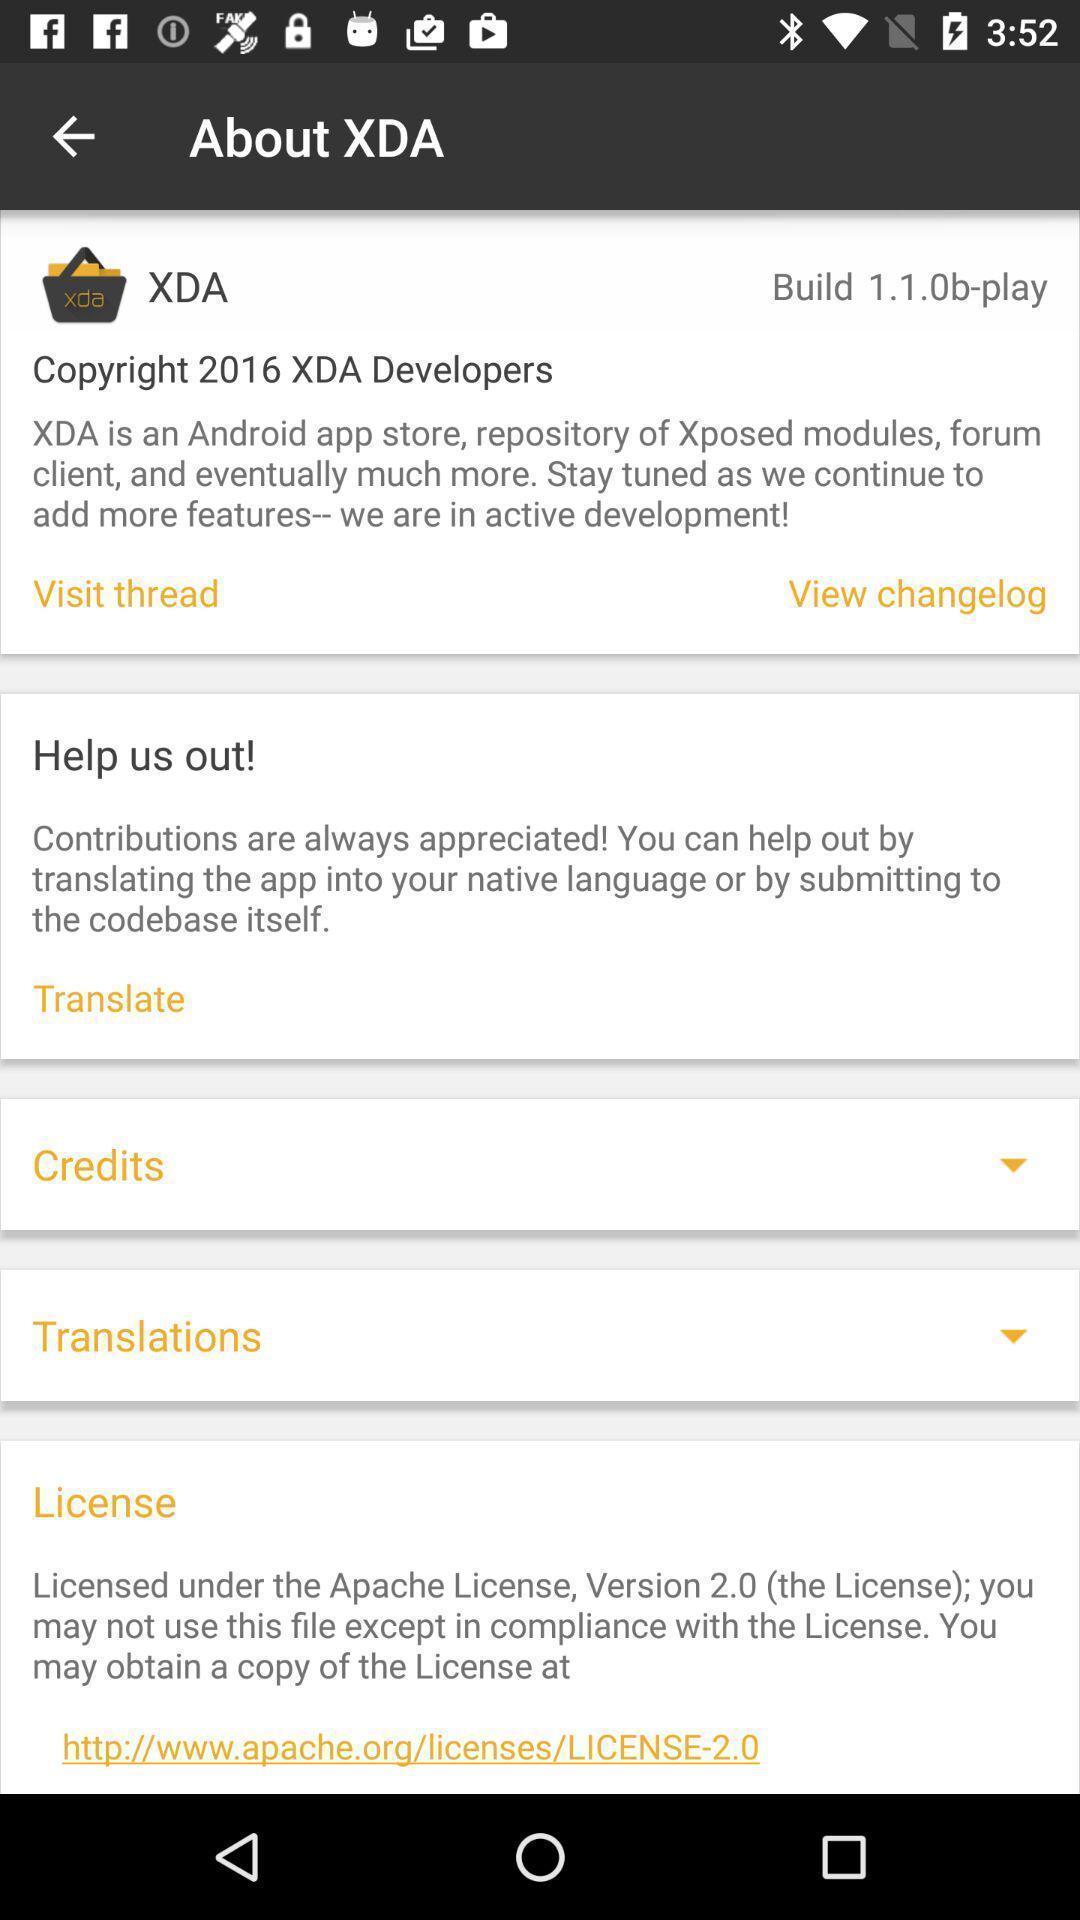Summarize the main components in this picture. Page showing different information about application. 